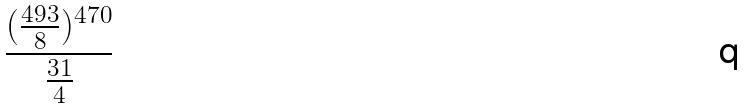<formula> <loc_0><loc_0><loc_500><loc_500>\frac { ( \frac { 4 9 3 } { 8 } ) ^ { 4 7 0 } } { \frac { 3 1 } { 4 } }</formula> 